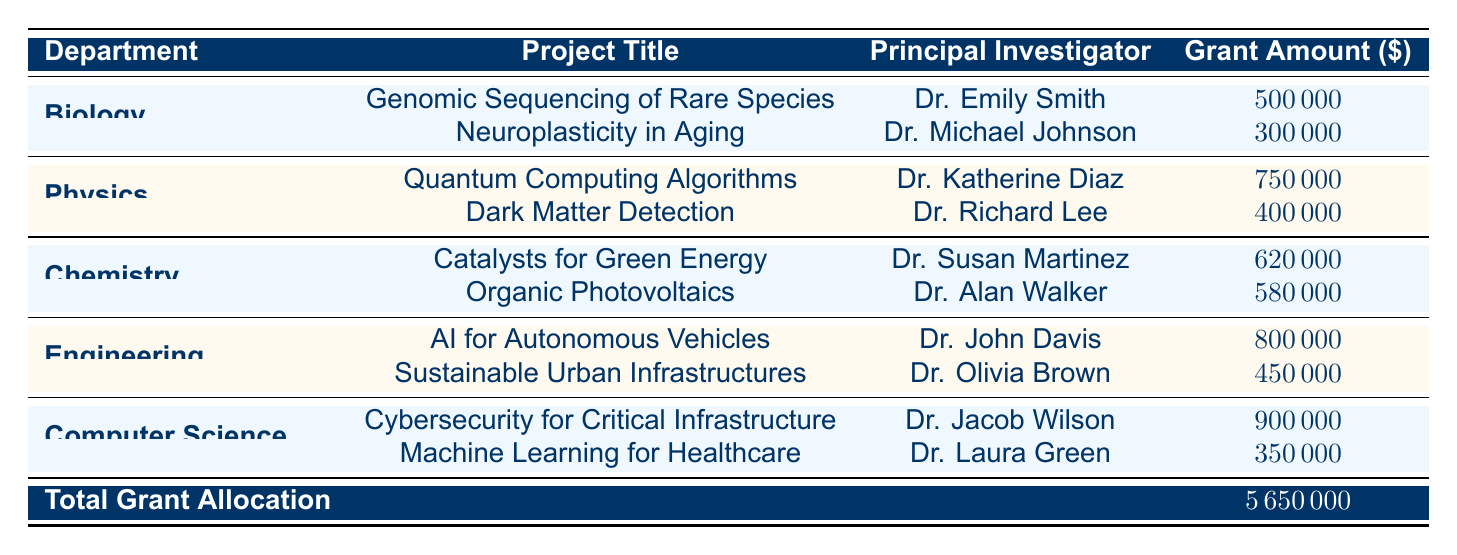What is the total grant amount for the Chemistry department? The table lists the total grant amount for each department. By looking directly under the Chemistry department, we see the total grant amount specified as 1200000.
Answer: 1200000 Who is the principal investigator for the project "AI for Autonomous Vehicles"? The table includes information about various projects, including their principal investigators. By searching for the project title "AI for Autonomous Vehicles," we find that Dr. John Davis is the principal investigator associated with this project.
Answer: Dr. John Davis What is the average grant amount allocated to projects in the Computer Science department? The total grant amount for Computer Science is given as 1250000, and there are two projects listed in this department. To find the average, divide 1250000 by 2, which equals 625000.
Answer: 625000 Did the Biology department receive more total grant funding than the Physics department? The total grant amount for Biology is 800000, while for Physics, it is 1150000. To determine if Biology received more funding, we compare these two totals and see that 800000 is less than 1150000. Therefore, the statement is false.
Answer: No What is the sum of grant amounts for all projects in the Engineering department? To find the total grant amounts for the Engineering department, we look at the two projects listed: "AI for Autonomous Vehicles" with 800000 and "Sustainable Urban Infrastructures" with 450000. Summing these gives 800000 + 450000 = 1250000, which matches the total grant amount stated for Engineering.
Answer: 1250000 What is the funding source for the project titled "Cybersecurity for Critical Infrastructure"? The table lists the projects along with their funding sources. By locating the project "Cybersecurity for Critical Infrastructure," we see that the funding source is the Cybersecurity and Infrastructure Security Agency.
Answer: Cybersecurity and Infrastructure Security Agency Are there more projects listed in the Chemistry department than in the Biology department? The Chemistry department has two projects listed: "Catalysts for Green Energy" and "Organic Photovoltaics." The Biology department also has two projects: "Genomic Sequencing of Rare Species" and "Neuroplasticity in Aging." Since both departments have the same number of projects, the statement is false.
Answer: No What is the total grant allocation across all departments? The table provides a specific value labeled as "Total Grant Allocation," which sums the grant amounts for all departments. The total given is 5650000. Therefore, this is the total grant allocation.
Answer: 5650000 What grant amount is associated with the project "Dark Matter Detection"? The project "Dark Matter Detection" is in the Physics department, and according to the table, its grant amount is stated as 400000.
Answer: 400000 